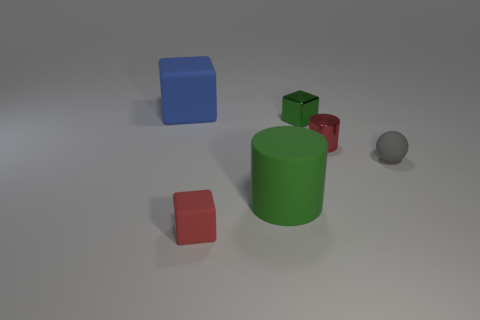Add 1 matte spheres. How many objects exist? 7 Subtract all cylinders. How many objects are left? 4 Subtract 0 brown cylinders. How many objects are left? 6 Subtract all tiny brown blocks. Subtract all tiny cubes. How many objects are left? 4 Add 4 rubber objects. How many rubber objects are left? 8 Add 2 tiny gray matte cylinders. How many tiny gray matte cylinders exist? 2 